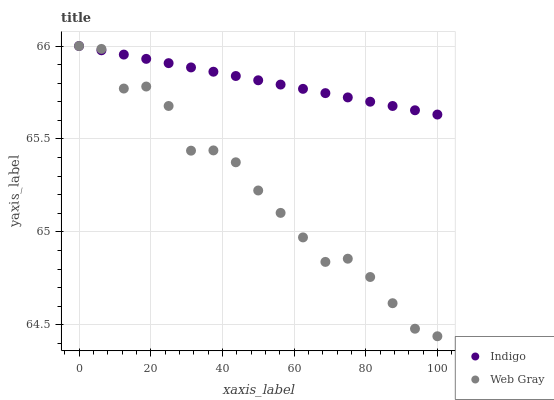Does Web Gray have the minimum area under the curve?
Answer yes or no. Yes. Does Indigo have the maximum area under the curve?
Answer yes or no. Yes. Does Indigo have the minimum area under the curve?
Answer yes or no. No. Is Indigo the smoothest?
Answer yes or no. Yes. Is Web Gray the roughest?
Answer yes or no. Yes. Is Indigo the roughest?
Answer yes or no. No. Does Web Gray have the lowest value?
Answer yes or no. Yes. Does Indigo have the lowest value?
Answer yes or no. No. Does Indigo have the highest value?
Answer yes or no. Yes. Does Web Gray intersect Indigo?
Answer yes or no. Yes. Is Web Gray less than Indigo?
Answer yes or no. No. Is Web Gray greater than Indigo?
Answer yes or no. No. 